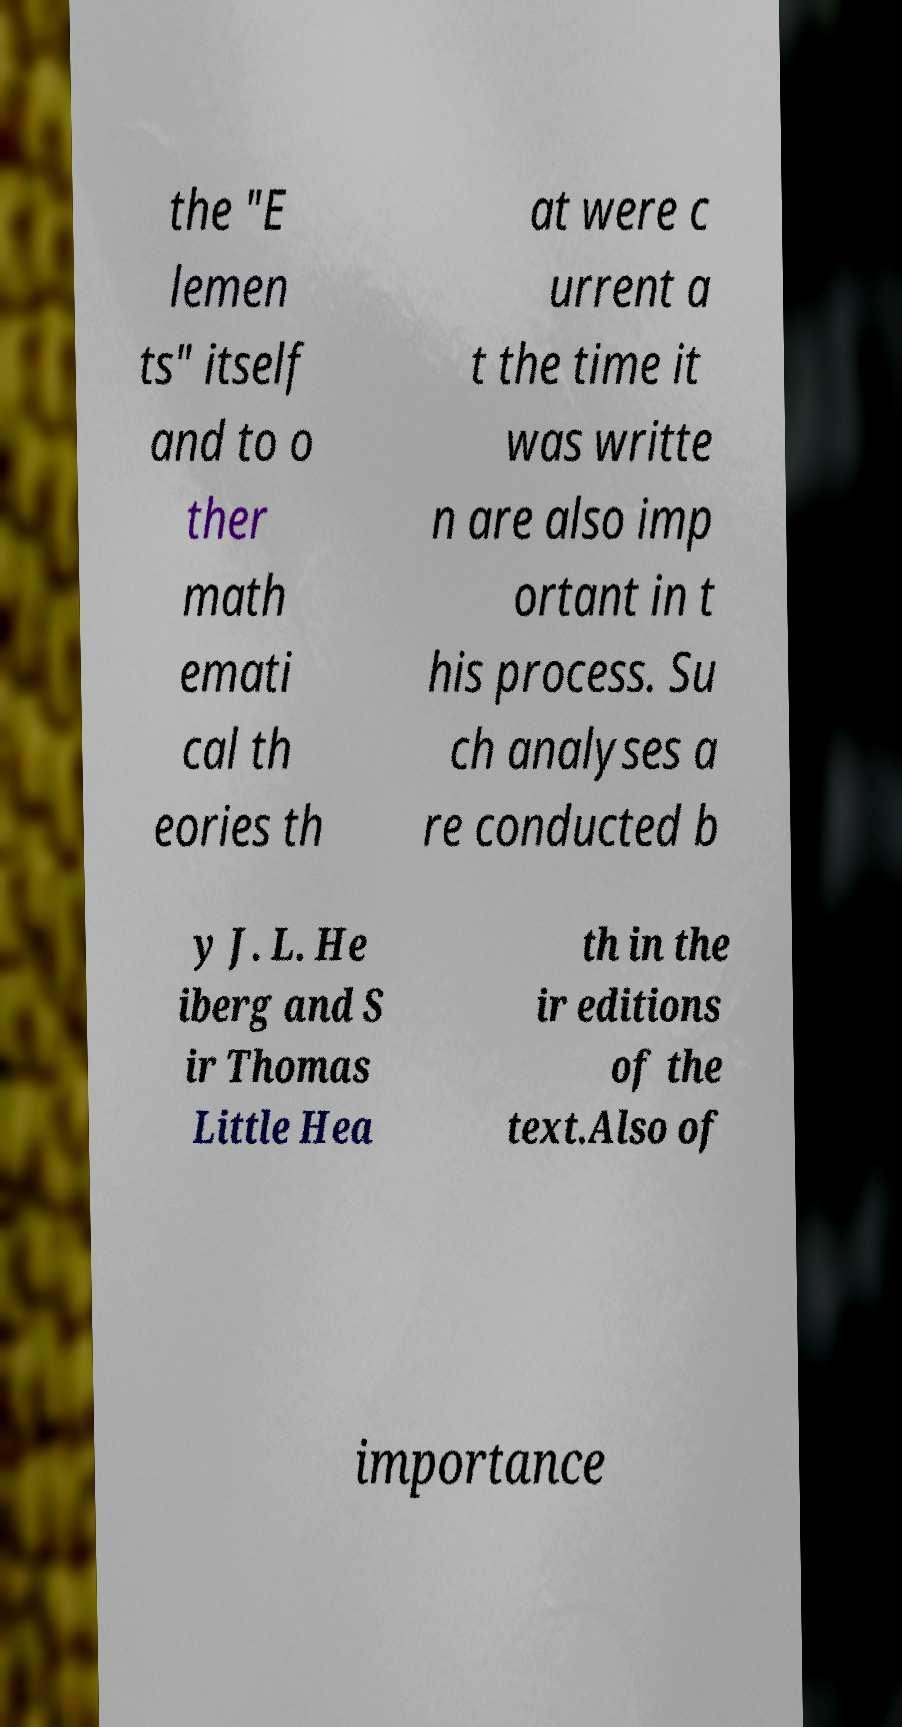What messages or text are displayed in this image? I need them in a readable, typed format. the "E lemen ts" itself and to o ther math emati cal th eories th at were c urrent a t the time it was writte n are also imp ortant in t his process. Su ch analyses a re conducted b y J. L. He iberg and S ir Thomas Little Hea th in the ir editions of the text.Also of importance 